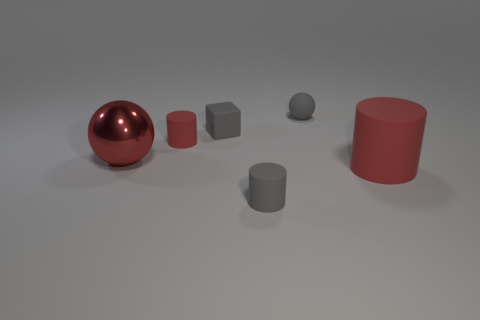Subtract all gray spheres. How many red cylinders are left? 2 Add 4 green metallic cylinders. How many objects exist? 10 Subtract all cyan cylinders. Subtract all purple blocks. How many cylinders are left? 3 Subtract all balls. How many objects are left? 4 Subtract all big shiny things. Subtract all large red metallic things. How many objects are left? 4 Add 3 large metallic things. How many large metallic things are left? 4 Add 6 green rubber things. How many green rubber things exist? 6 Subtract 0 brown cubes. How many objects are left? 6 